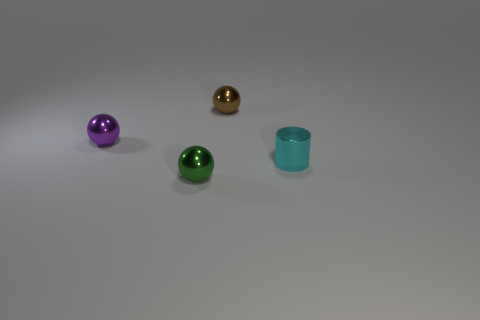Subtract all green balls. How many balls are left? 2 Add 3 tiny green metallic spheres. How many objects exist? 7 Subtract all balls. How many objects are left? 1 Subtract all blue spheres. Subtract all cyan cylinders. How many spheres are left? 3 Add 1 tiny cyan metal objects. How many tiny cyan metal objects are left? 2 Add 4 tiny cyan shiny cylinders. How many tiny cyan shiny cylinders exist? 5 Subtract 0 brown blocks. How many objects are left? 4 Subtract all green shiny balls. Subtract all purple balls. How many objects are left? 2 